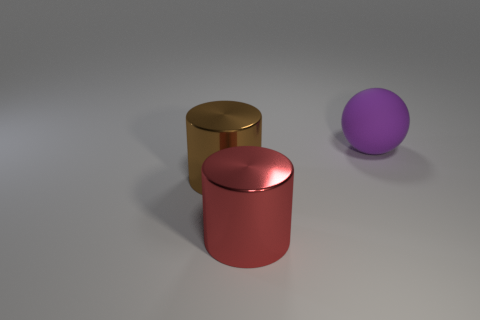Is there any other thing that has the same material as the large purple ball?
Your response must be concise. No. What number of metal cylinders are the same color as the ball?
Offer a very short reply. 0. How many objects are large objects in front of the big brown shiny cylinder or brown shiny cylinders?
Your answer should be compact. 2. What size is the metallic cylinder that is to the left of the red shiny object?
Your answer should be compact. Large. Is the number of big purple objects less than the number of tiny cylinders?
Make the answer very short. No. Is the material of the big object that is to the left of the red cylinder the same as the large thing that is behind the brown metal thing?
Your answer should be compact. No. What shape is the large metallic object to the right of the large shiny object that is left of the big metal cylinder that is in front of the large brown object?
Your answer should be very brief. Cylinder. What number of purple things are the same material as the red cylinder?
Ensure brevity in your answer.  0. How many purple rubber balls are to the left of the cylinder right of the brown object?
Provide a short and direct response. 0. The big object that is both in front of the large purple rubber thing and on the right side of the large brown object has what shape?
Offer a terse response. Cylinder. 